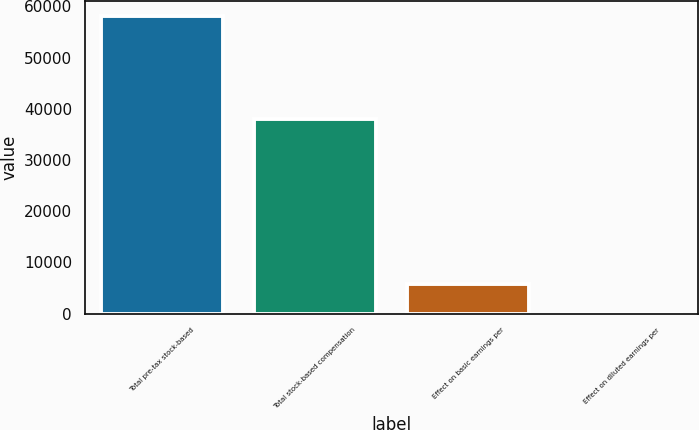Convert chart to OTSL. <chart><loc_0><loc_0><loc_500><loc_500><bar_chart><fcel>Total pre-tax stock-based<fcel>Total stock-based compensation<fcel>Effect on basic earnings per<fcel>Effect on diluted earnings per<nl><fcel>58134<fcel>37982<fcel>5818.52<fcel>5.69<nl></chart> 